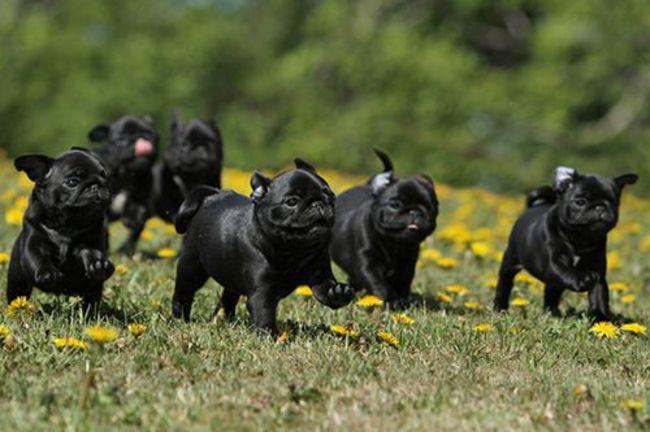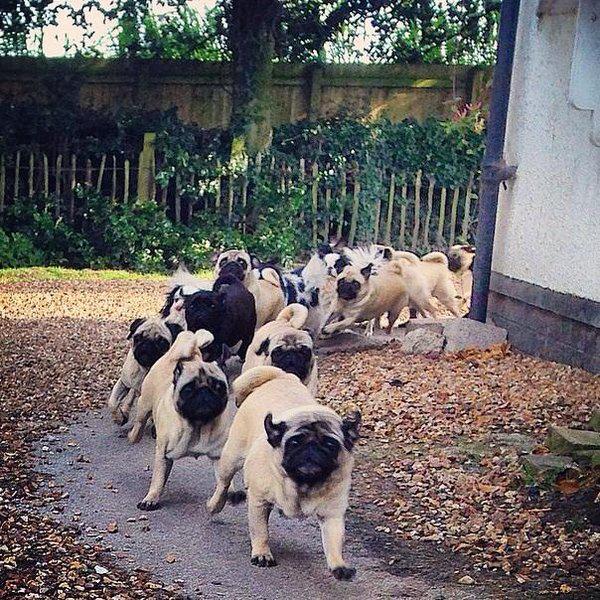The first image is the image on the left, the second image is the image on the right. Assess this claim about the two images: "A group of brown boxer puppies are indoors in one of the images, and at least two of those are looking at the camera.". Correct or not? Answer yes or no. No. The first image is the image on the left, the second image is the image on the right. Examine the images to the left and right. Is the description "Pugs are huddled together on a gray tiled floor" accurate? Answer yes or no. No. 